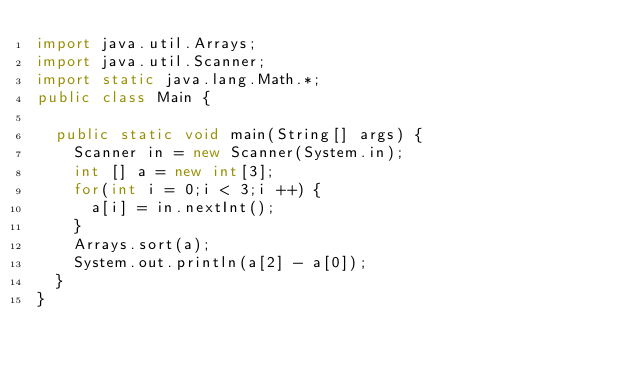Convert code to text. <code><loc_0><loc_0><loc_500><loc_500><_Java_>import java.util.Arrays;
import java.util.Scanner;
import static java.lang.Math.*;
public class Main {
	
	public static void main(String[] args) {
		Scanner in = new Scanner(System.in);
		int [] a = new int[3];
		for(int i = 0;i < 3;i ++) {
			a[i] = in.nextInt();
		}
		Arrays.sort(a);
		System.out.println(a[2] - a[0]);
	}
}
</code> 